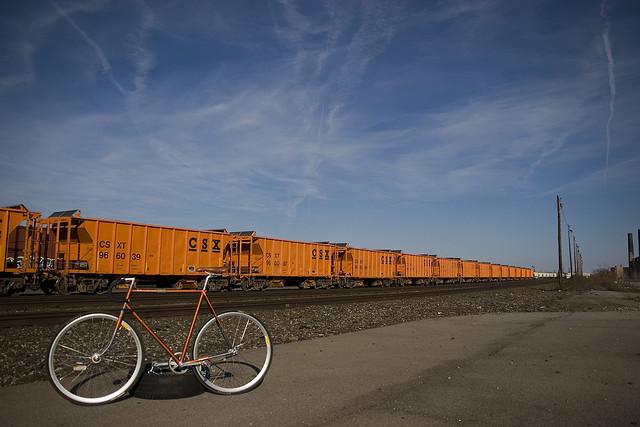Is this train in a flatland?
Answer briefly. Yes. Is the bike on a chain?
Short answer required. No. How many trees are visible on the right side of the train?
Keep it brief. 0. How many bicycles are pictured?
Be succinct. 1. Is this an active train?
Write a very short answer. Yes. Where is the bicycle?
Keep it brief. Road. What kind of vehicles are shown?
Short answer required. Train. Could this be a gravel road?
Concise answer only. No. What is behind the bike?
Give a very brief answer. Train. Is the sun in the sky?
Write a very short answer. No. 